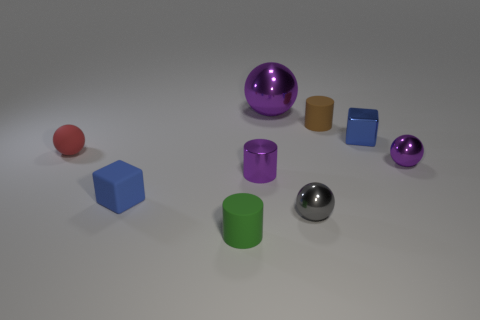Subtract all spheres. How many objects are left? 5 Subtract 0 gray cylinders. How many objects are left? 9 Subtract all red things. Subtract all gray metallic things. How many objects are left? 7 Add 3 tiny shiny spheres. How many tiny shiny spheres are left? 5 Add 6 tiny green cylinders. How many tiny green cylinders exist? 7 